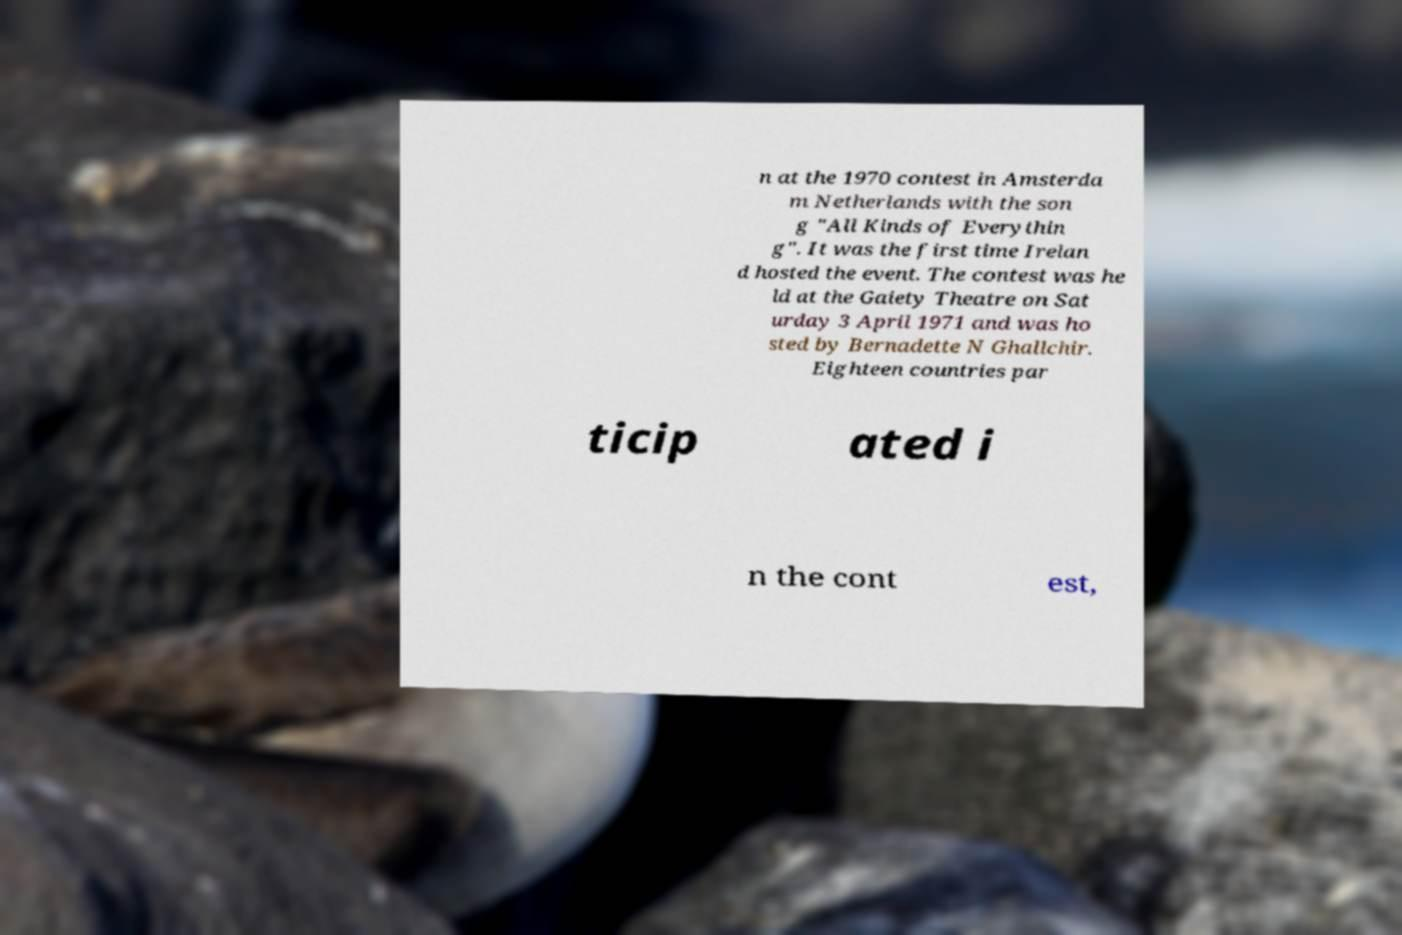Can you read and provide the text displayed in the image?This photo seems to have some interesting text. Can you extract and type it out for me? n at the 1970 contest in Amsterda m Netherlands with the son g "All Kinds of Everythin g". It was the first time Irelan d hosted the event. The contest was he ld at the Gaiety Theatre on Sat urday 3 April 1971 and was ho sted by Bernadette N Ghallchir. Eighteen countries par ticip ated i n the cont est, 